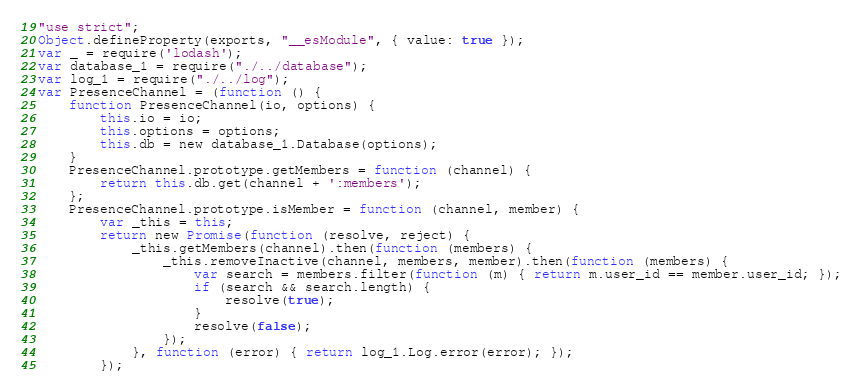Convert code to text. <code><loc_0><loc_0><loc_500><loc_500><_JavaScript_>"use strict";
Object.defineProperty(exports, "__esModule", { value: true });
var _ = require('lodash');
var database_1 = require("./../database");
var log_1 = require("./../log");
var PresenceChannel = (function () {
    function PresenceChannel(io, options) {
        this.io = io;
        this.options = options;
        this.db = new database_1.Database(options);
    }
    PresenceChannel.prototype.getMembers = function (channel) {
        return this.db.get(channel + ':members');
    };
    PresenceChannel.prototype.isMember = function (channel, member) {
        var _this = this;
        return new Promise(function (resolve, reject) {
            _this.getMembers(channel).then(function (members) {
                _this.removeInactive(channel, members, member).then(function (members) {
                    var search = members.filter(function (m) { return m.user_id == member.user_id; });
                    if (search && search.length) {
                        resolve(true);
                    }
                    resolve(false);
                });
            }, function (error) { return log_1.Log.error(error); });
        });</code> 